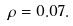Convert formula to latex. <formula><loc_0><loc_0><loc_500><loc_500>\rho = 0 . 0 7 .</formula> 